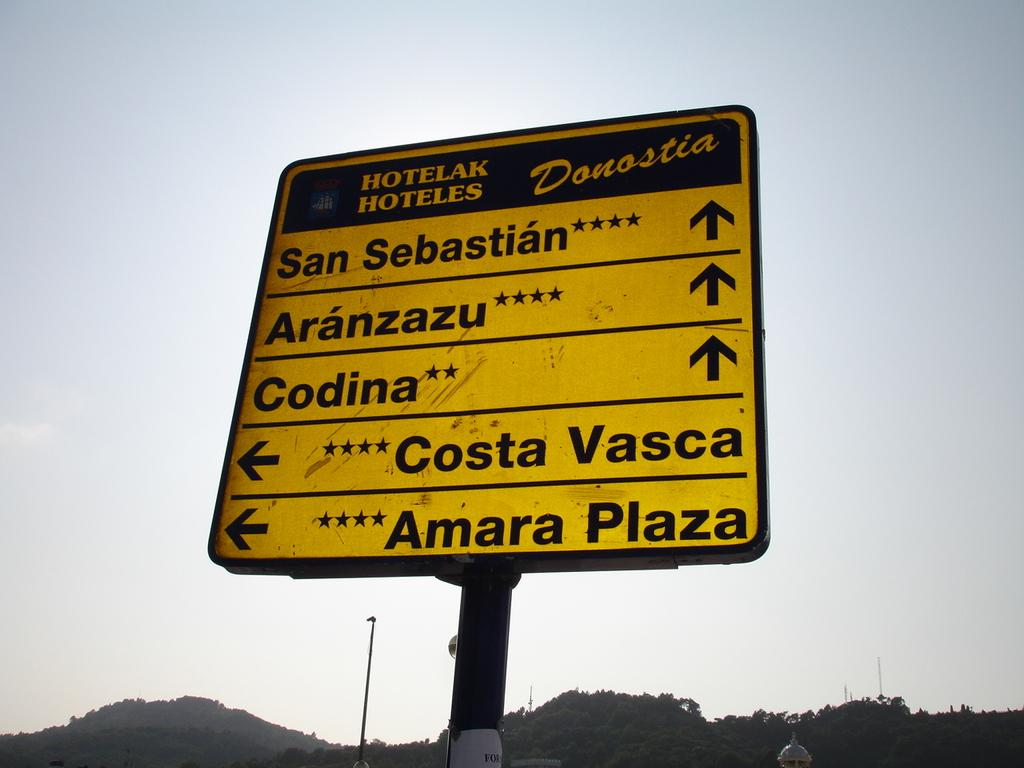<image>
Provide a brief description of the given image. Large road sign that has "Hotelak Hoteles" on the top. 